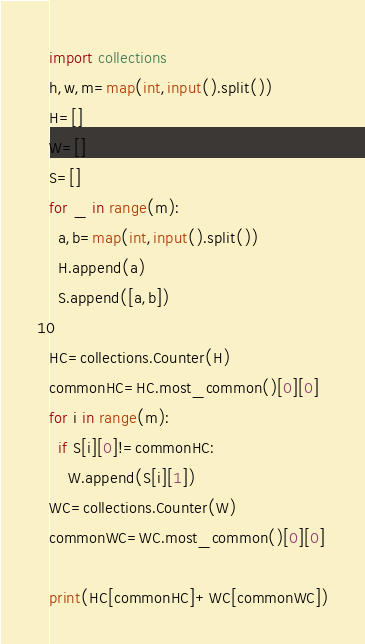Convert code to text. <code><loc_0><loc_0><loc_500><loc_500><_Python_>import collections
h,w,m=map(int,input().split())
H=[]
W=[]
S=[]
for _ in range(m):
  a,b=map(int,input().split())
  H.append(a)
  S.append([a,b])
  
HC=collections.Counter(H)
commonHC=HC.most_common()[0][0]
for i in range(m):
  if S[i][0]!=commonHC:
    W.append(S[i][1])
WC=collections.Counter(W)
commonWC=WC.most_common()[0][0]

print(HC[commonHC]+WC[commonWC])</code> 